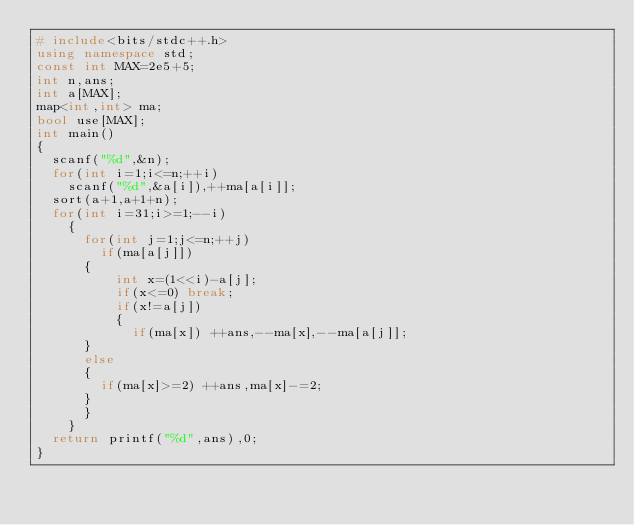Convert code to text. <code><loc_0><loc_0><loc_500><loc_500><_C++_># include<bits/stdc++.h>
using namespace std;
const int MAX=2e5+5;
int n,ans;
int a[MAX];
map<int,int> ma;
bool use[MAX];
int main()
{
	scanf("%d",&n);
	for(int i=1;i<=n;++i)
	  scanf("%d",&a[i]),++ma[a[i]];
	sort(a+1,a+1+n);
	for(int i=31;i>=1;--i)
	  {
	  	for(int j=1;j<=n;++j)
	  	  if(ma[a[j]])
		  {
	  	  	int x=(1<<i)-a[j];
	  	  	if(x<=0) break;
	  	  	if(x!=a[j])
	  	  	{
	  	  		if(ma[x]) ++ans,--ma[x],--ma[a[j]];
			}
			else
			{
				if(ma[x]>=2) ++ans,ma[x]-=2;
			}
		  }
	  }
	return printf("%d",ans),0;
}</code> 